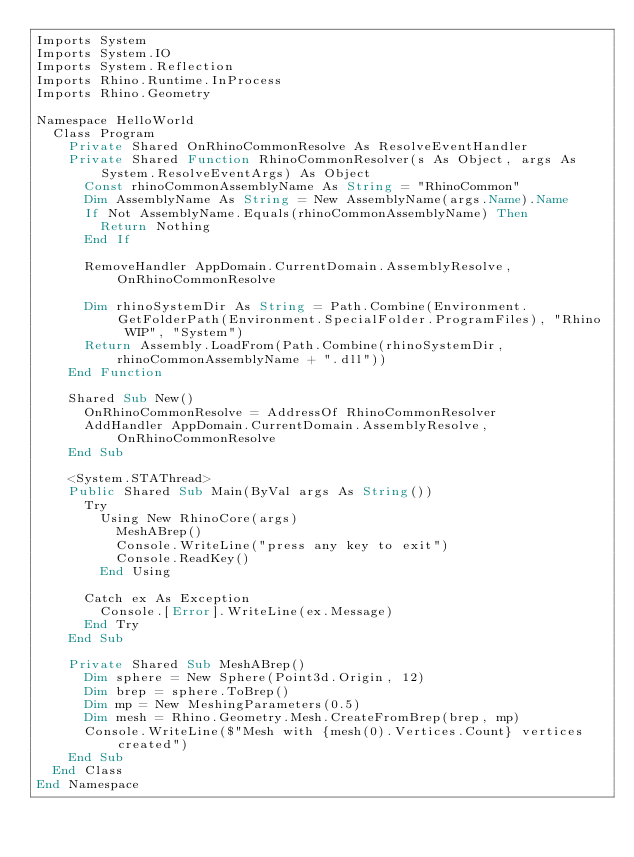<code> <loc_0><loc_0><loc_500><loc_500><_VisualBasic_>Imports System
Imports System.IO
Imports System.Reflection
Imports Rhino.Runtime.InProcess
Imports Rhino.Geometry

Namespace HelloWorld
  Class Program
    Private Shared OnRhinoCommonResolve As ResolveEventHandler
    Private Shared Function RhinoCommonResolver(s As Object, args As System.ResolveEventArgs) As Object
      Const rhinoCommonAssemblyName As String = "RhinoCommon"
      Dim AssemblyName As String = New AssemblyName(args.Name).Name
      If Not AssemblyName.Equals(rhinoCommonAssemblyName) Then
        Return Nothing
      End If

      RemoveHandler AppDomain.CurrentDomain.AssemblyResolve, OnRhinoCommonResolve

      Dim rhinoSystemDir As String = Path.Combine(Environment.GetFolderPath(Environment.SpecialFolder.ProgramFiles), "Rhino WIP", "System")
      Return Assembly.LoadFrom(Path.Combine(rhinoSystemDir, rhinoCommonAssemblyName + ".dll"))
    End Function

    Shared Sub New()
      OnRhinoCommonResolve = AddressOf RhinoCommonResolver
      AddHandler AppDomain.CurrentDomain.AssemblyResolve, OnRhinoCommonResolve
    End Sub

    <System.STAThread>
    Public Shared Sub Main(ByVal args As String())
      Try
        Using New RhinoCore(args)
          MeshABrep()
          Console.WriteLine("press any key to exit")
          Console.ReadKey()
        End Using

      Catch ex As Exception
        Console.[Error].WriteLine(ex.Message)
      End Try
    End Sub

    Private Shared Sub MeshABrep()
      Dim sphere = New Sphere(Point3d.Origin, 12)
      Dim brep = sphere.ToBrep()
      Dim mp = New MeshingParameters(0.5)
      Dim mesh = Rhino.Geometry.Mesh.CreateFromBrep(brep, mp)
      Console.WriteLine($"Mesh with {mesh(0).Vertices.Count} vertices created")
    End Sub
  End Class
End Namespace
</code> 